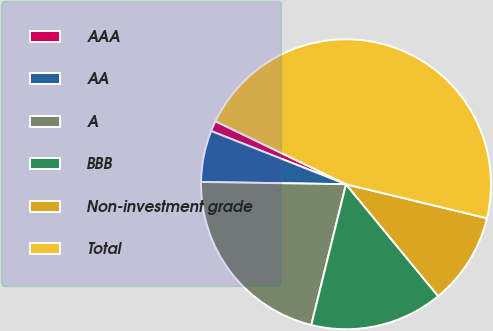Convert chart to OTSL. <chart><loc_0><loc_0><loc_500><loc_500><pie_chart><fcel>AAA<fcel>AA<fcel>A<fcel>BBB<fcel>Non-investment grade<fcel>Total<nl><fcel>1.18%<fcel>5.73%<fcel>21.4%<fcel>14.81%<fcel>10.27%<fcel>46.61%<nl></chart> 